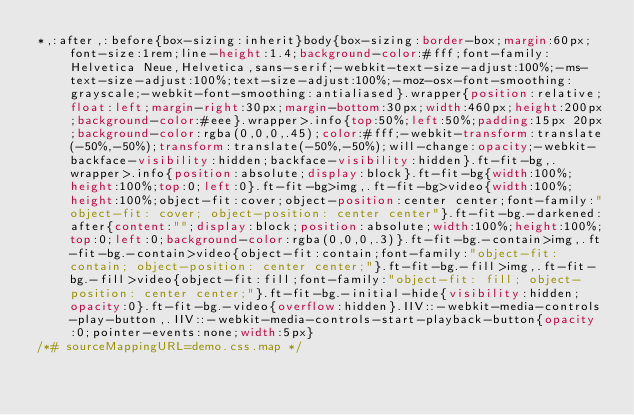<code> <loc_0><loc_0><loc_500><loc_500><_CSS_>*,:after,:before{box-sizing:inherit}body{box-sizing:border-box;margin:60px;font-size:1rem;line-height:1.4;background-color:#fff;font-family:Helvetica Neue,Helvetica,sans-serif;-webkit-text-size-adjust:100%;-ms-text-size-adjust:100%;text-size-adjust:100%;-moz-osx-font-smoothing:grayscale;-webkit-font-smoothing:antialiased}.wrapper{position:relative;float:left;margin-right:30px;margin-bottom:30px;width:460px;height:200px;background-color:#eee}.wrapper>.info{top:50%;left:50%;padding:15px 20px;background-color:rgba(0,0,0,.45);color:#fff;-webkit-transform:translate(-50%,-50%);transform:translate(-50%,-50%);will-change:opacity;-webkit-backface-visibility:hidden;backface-visibility:hidden}.ft-fit-bg,.wrapper>.info{position:absolute;display:block}.ft-fit-bg{width:100%;height:100%;top:0;left:0}.ft-fit-bg>img,.ft-fit-bg>video{width:100%;height:100%;object-fit:cover;object-position:center center;font-family:"object-fit: cover; object-position: center center"}.ft-fit-bg.-darkened:after{content:"";display:block;position:absolute;width:100%;height:100%;top:0;left:0;background-color:rgba(0,0,0,.3)}.ft-fit-bg.-contain>img,.ft-fit-bg.-contain>video{object-fit:contain;font-family:"object-fit: contain; object-position: center center;"}.ft-fit-bg.-fill>img,.ft-fit-bg.-fill>video{object-fit:fill;font-family:"object-fit: fill; object-position: center center;"}.ft-fit-bg.-initial-hide{visibility:hidden;opacity:0}.ft-fit-bg.-video{overflow:hidden}.IIV::-webkit-media-controls-play-button,.IIV::-webkit-media-controls-start-playback-button{opacity:0;pointer-events:none;width:5px}
/*# sourceMappingURL=demo.css.map */</code> 